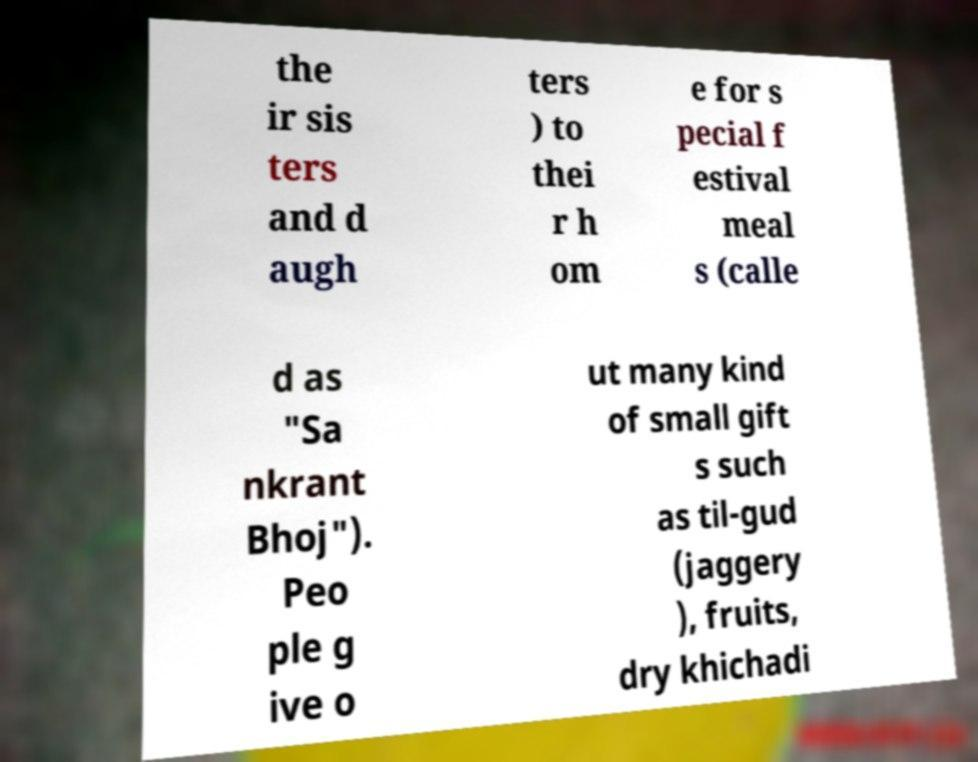I need the written content from this picture converted into text. Can you do that? the ir sis ters and d augh ters ) to thei r h om e for s pecial f estival meal s (calle d as "Sa nkrant Bhoj"). Peo ple g ive o ut many kind of small gift s such as til-gud (jaggery ), fruits, dry khichadi 